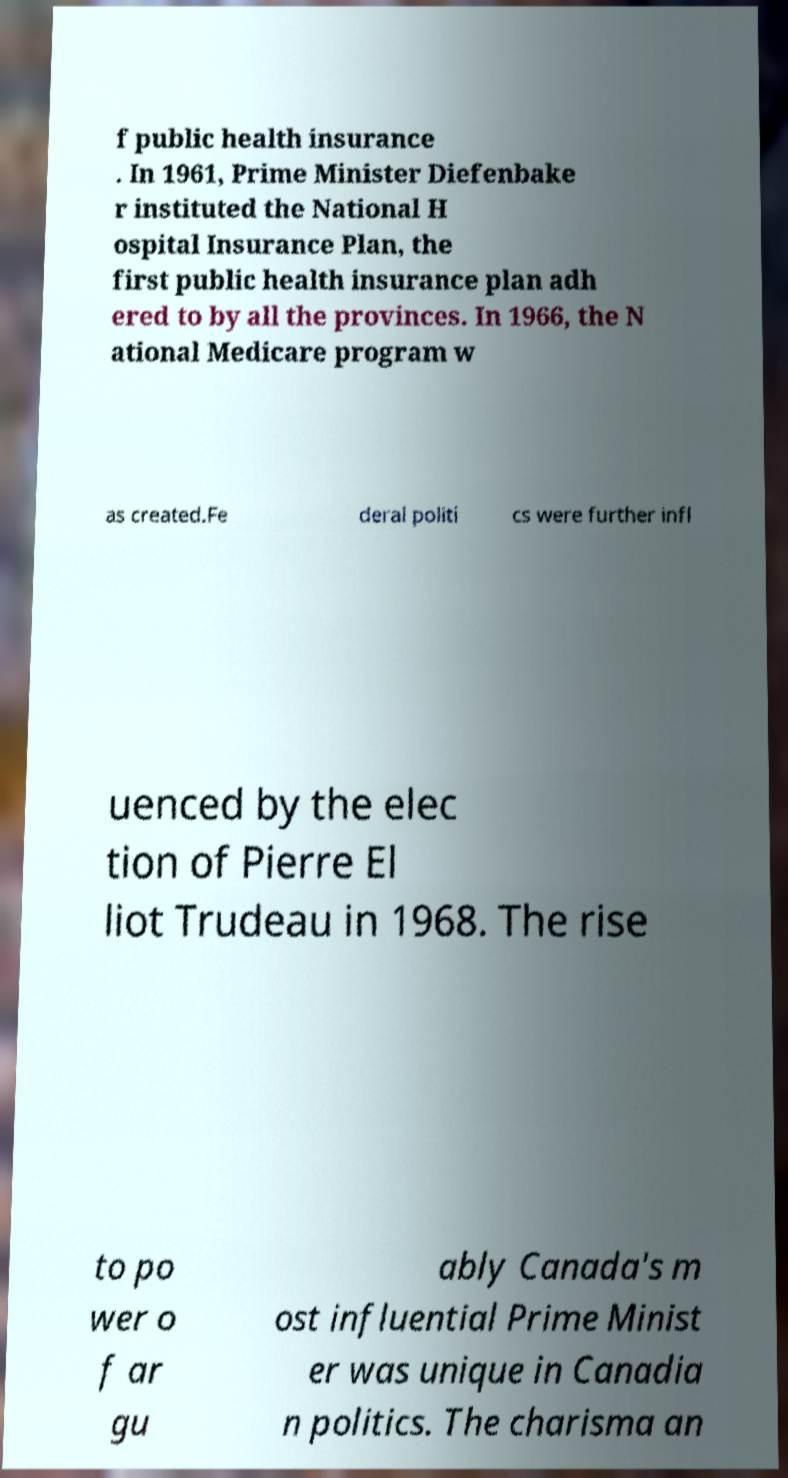For documentation purposes, I need the text within this image transcribed. Could you provide that? f public health insurance . In 1961, Prime Minister Diefenbake r instituted the National H ospital Insurance Plan, the first public health insurance plan adh ered to by all the provinces. In 1966, the N ational Medicare program w as created.Fe deral politi cs were further infl uenced by the elec tion of Pierre El liot Trudeau in 1968. The rise to po wer o f ar gu ably Canada's m ost influential Prime Minist er was unique in Canadia n politics. The charisma an 